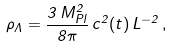Convert formula to latex. <formula><loc_0><loc_0><loc_500><loc_500>\rho _ { \Lambda } = \frac { 3 \, M _ { P l } ^ { 2 } } { 8 \pi } \, c ^ { 2 } ( t ) \, L ^ { - 2 } \, ,</formula> 